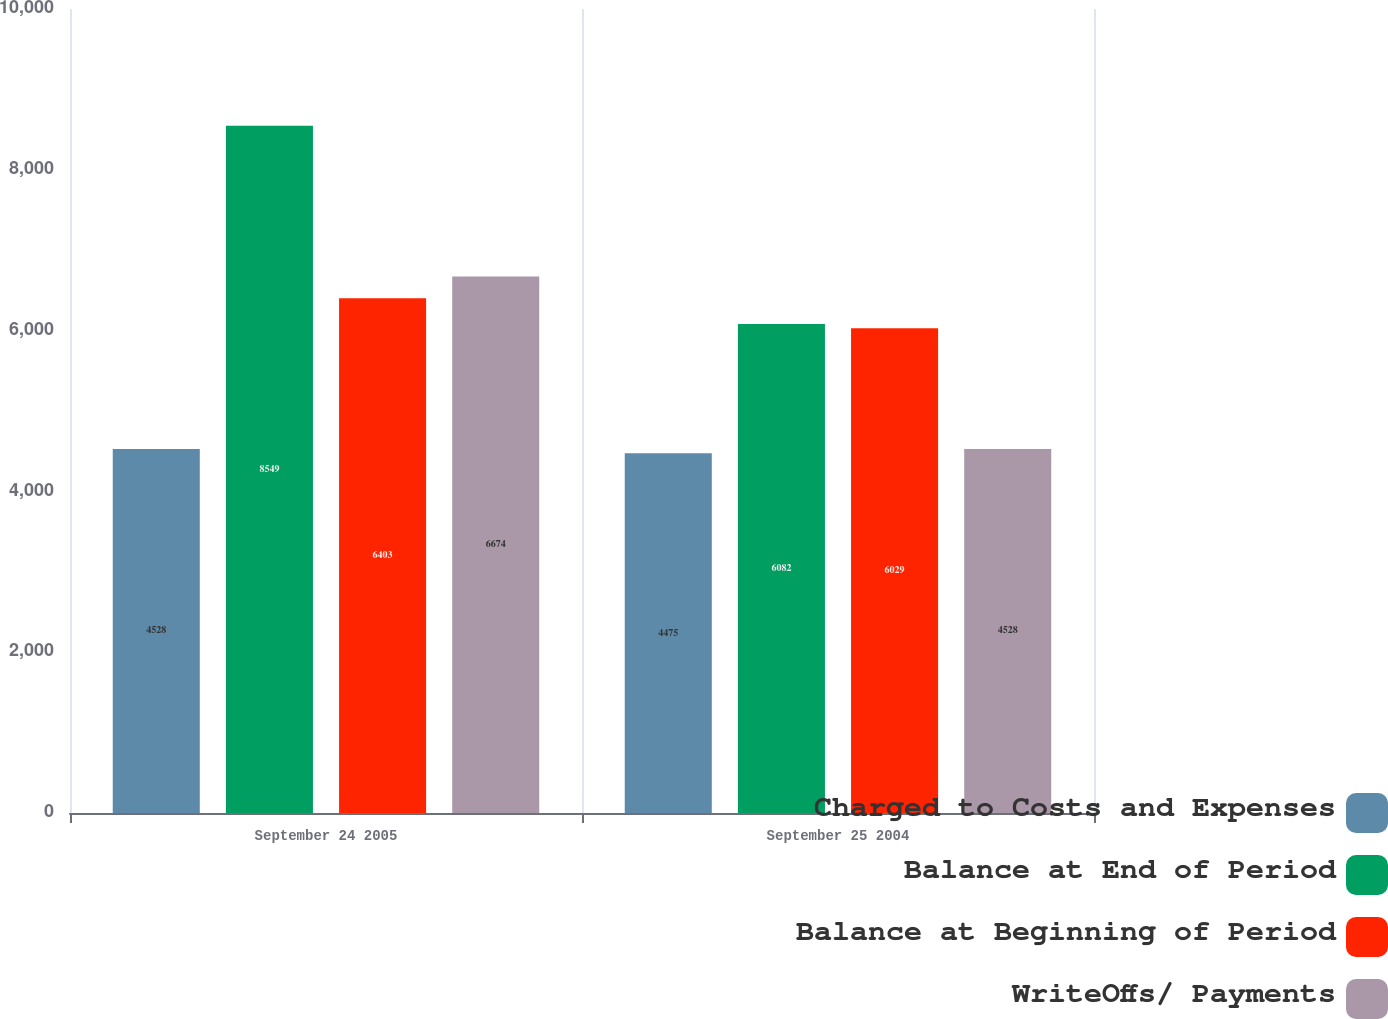Convert chart to OTSL. <chart><loc_0><loc_0><loc_500><loc_500><stacked_bar_chart><ecel><fcel>September 24 2005<fcel>September 25 2004<nl><fcel>Charged to Costs and Expenses<fcel>4528<fcel>4475<nl><fcel>Balance at End of Period<fcel>8549<fcel>6082<nl><fcel>Balance at Beginning of Period<fcel>6403<fcel>6029<nl><fcel>WriteOffs/ Payments<fcel>6674<fcel>4528<nl></chart> 